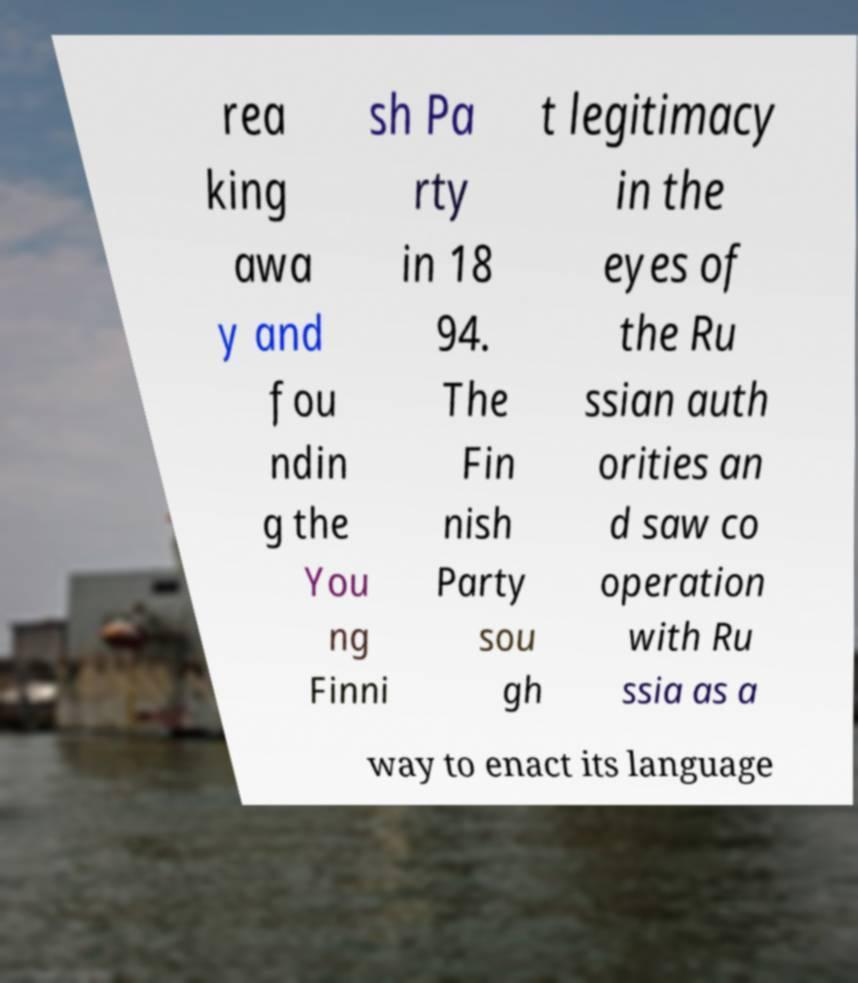There's text embedded in this image that I need extracted. Can you transcribe it verbatim? rea king awa y and fou ndin g the You ng Finni sh Pa rty in 18 94. The Fin nish Party sou gh t legitimacy in the eyes of the Ru ssian auth orities an d saw co operation with Ru ssia as a way to enact its language 